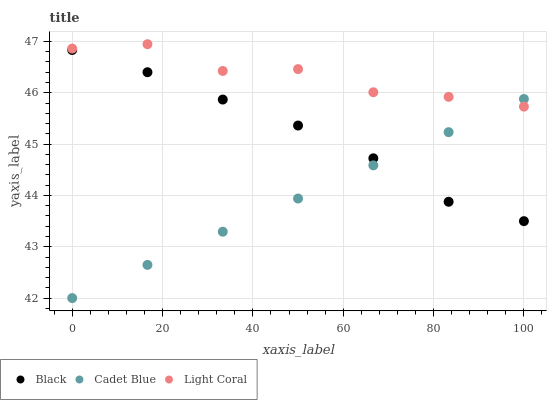Does Cadet Blue have the minimum area under the curve?
Answer yes or no. Yes. Does Light Coral have the maximum area under the curve?
Answer yes or no. Yes. Does Black have the minimum area under the curve?
Answer yes or no. No. Does Black have the maximum area under the curve?
Answer yes or no. No. Is Cadet Blue the smoothest?
Answer yes or no. Yes. Is Light Coral the roughest?
Answer yes or no. Yes. Is Black the smoothest?
Answer yes or no. No. Is Black the roughest?
Answer yes or no. No. Does Cadet Blue have the lowest value?
Answer yes or no. Yes. Does Black have the lowest value?
Answer yes or no. No. Does Light Coral have the highest value?
Answer yes or no. Yes. Does Black have the highest value?
Answer yes or no. No. Is Black less than Light Coral?
Answer yes or no. Yes. Is Light Coral greater than Black?
Answer yes or no. Yes. Does Light Coral intersect Cadet Blue?
Answer yes or no. Yes. Is Light Coral less than Cadet Blue?
Answer yes or no. No. Is Light Coral greater than Cadet Blue?
Answer yes or no. No. Does Black intersect Light Coral?
Answer yes or no. No. 